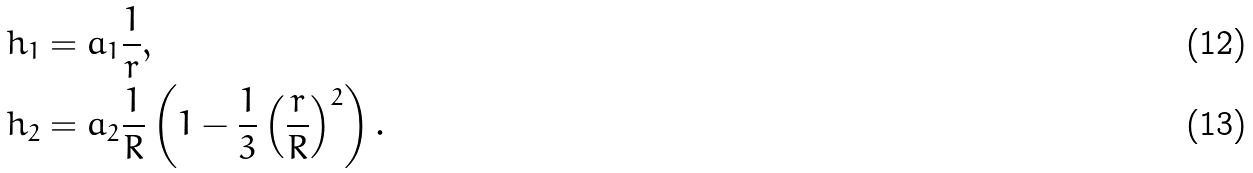Convert formula to latex. <formula><loc_0><loc_0><loc_500><loc_500>h _ { 1 } & = a _ { 1 } \frac { 1 } { r } , \\ h _ { 2 } & = a _ { 2 } \frac { 1 } { R } \left ( 1 - \frac { 1 } { 3 } \left ( \frac { r } { R } \right ) ^ { 2 } \right ) .</formula> 